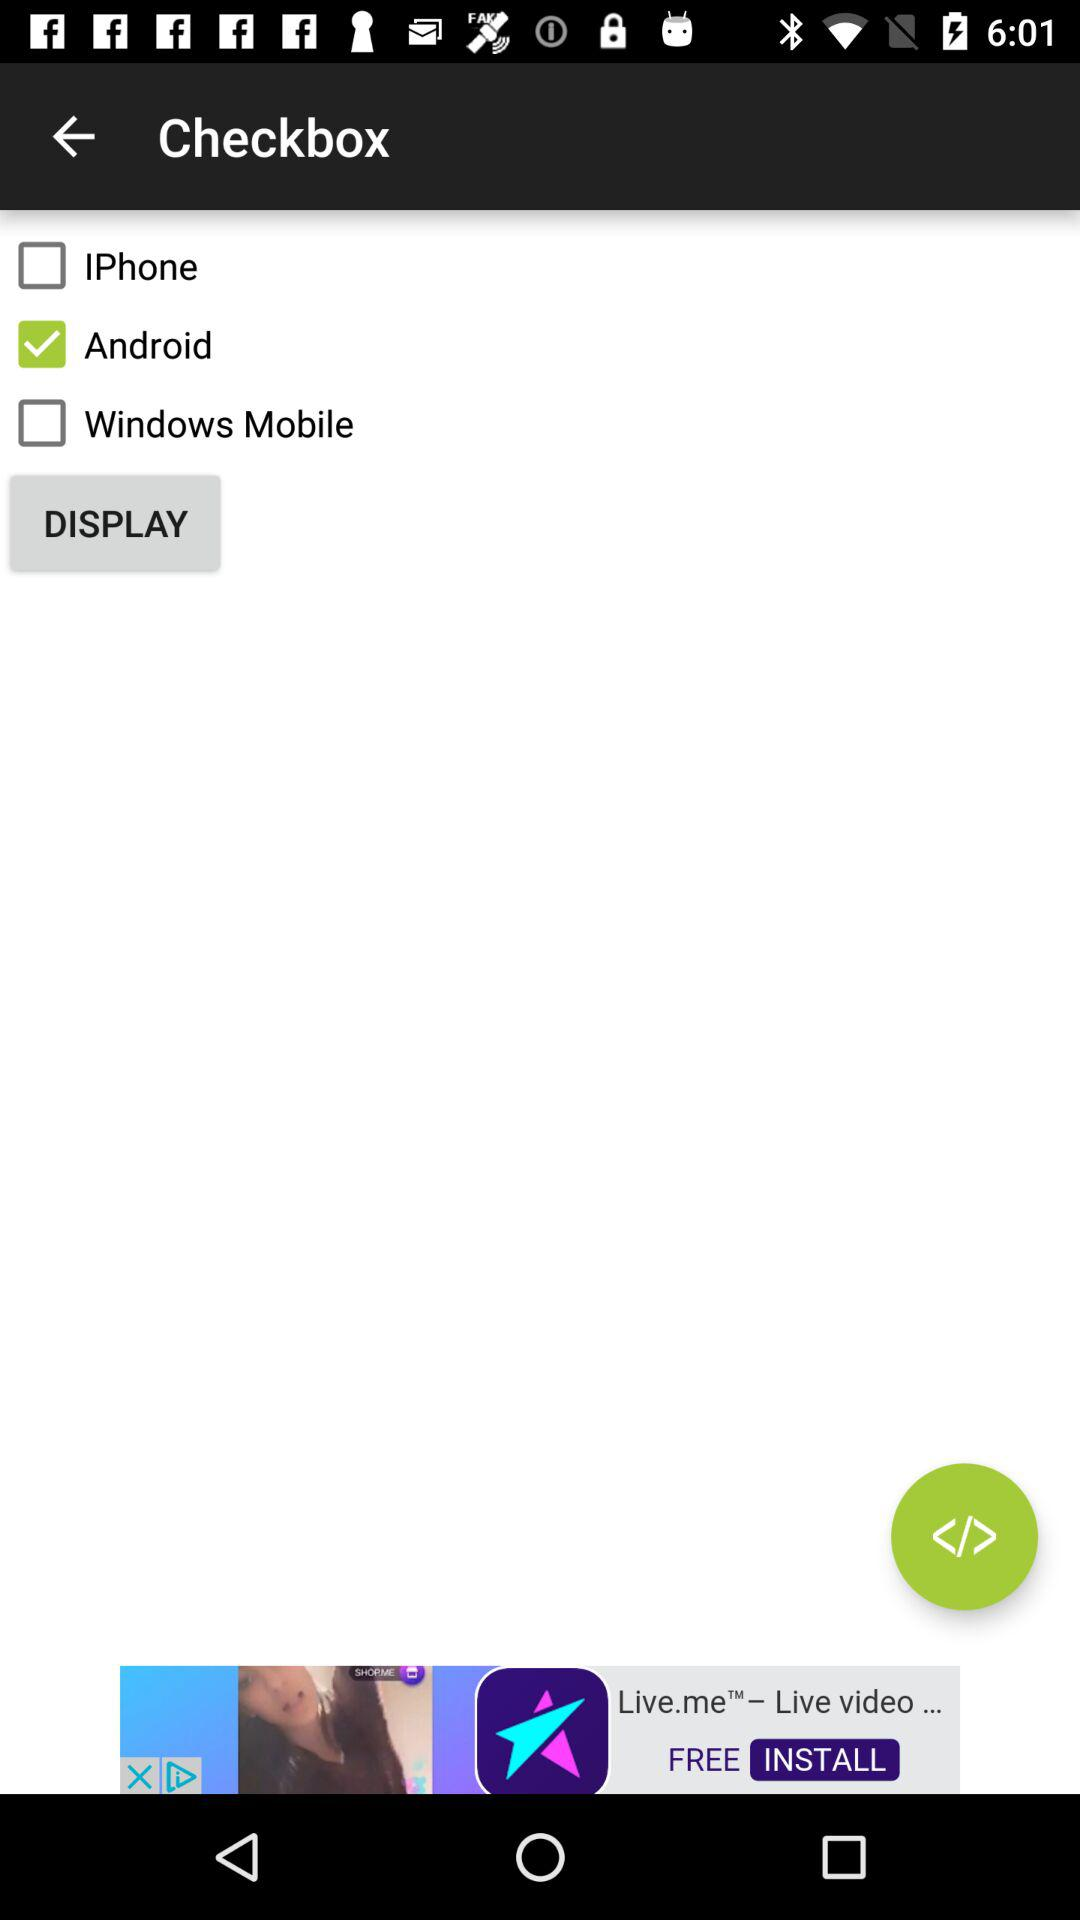What mobile operating systems are listed in the checkboxes? The image displays checkboxes for three mobile operating systems: 'IPhone', 'Android', and 'Windows Mobile'. 